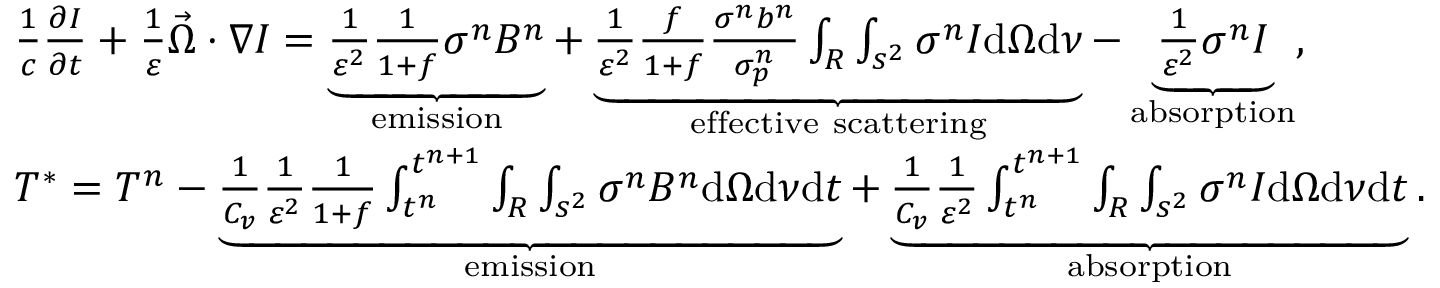Convert formula to latex. <formula><loc_0><loc_0><loc_500><loc_500>\begin{array} { r l } & { \frac { 1 } { c } \frac { \partial I } { \partial t } + \frac { 1 } { \varepsilon } \vec { \Omega } \cdot \nabla I = \underbrace { \frac { 1 } { \varepsilon ^ { 2 } } \frac { 1 } { 1 + f } \sigma ^ { n } B ^ { n } } _ { e m i s s i o n } + \underbrace { \frac { 1 } { \varepsilon ^ { 2 } } \frac { f } { 1 + f } \frac { \sigma ^ { n } b ^ { n } } { \sigma _ { p } ^ { n } } \int _ { R } \int _ { s ^ { 2 } } \sigma ^ { n } I d \Omega d \nu } _ { e f f e c t i v e s c a t t e r i n g } - \underbrace { \frac { 1 } { \varepsilon ^ { 2 } } \sigma ^ { n } I } _ { a b s o r p t i o n } , } \\ & { T ^ { * } = T ^ { n } - \underbrace { \frac { 1 } { C _ { v } } \frac { 1 } { \varepsilon ^ { 2 } } \frac { 1 } { 1 + f } \int _ { t ^ { n } } ^ { t ^ { n + 1 } } \int _ { R } \int _ { s ^ { 2 } } \sigma ^ { n } B ^ { n } d \Omega d \nu d t } _ { e m i s s i o n } + \underbrace { \frac { 1 } { C _ { v } } \frac { 1 } { \varepsilon ^ { 2 } } \int _ { t ^ { n } } ^ { t ^ { n + 1 } } \int _ { R } \int _ { s ^ { 2 } } \sigma ^ { n } I d \Omega d \nu d t } _ { a b s o r p t i o n } . } \end{array}</formula> 